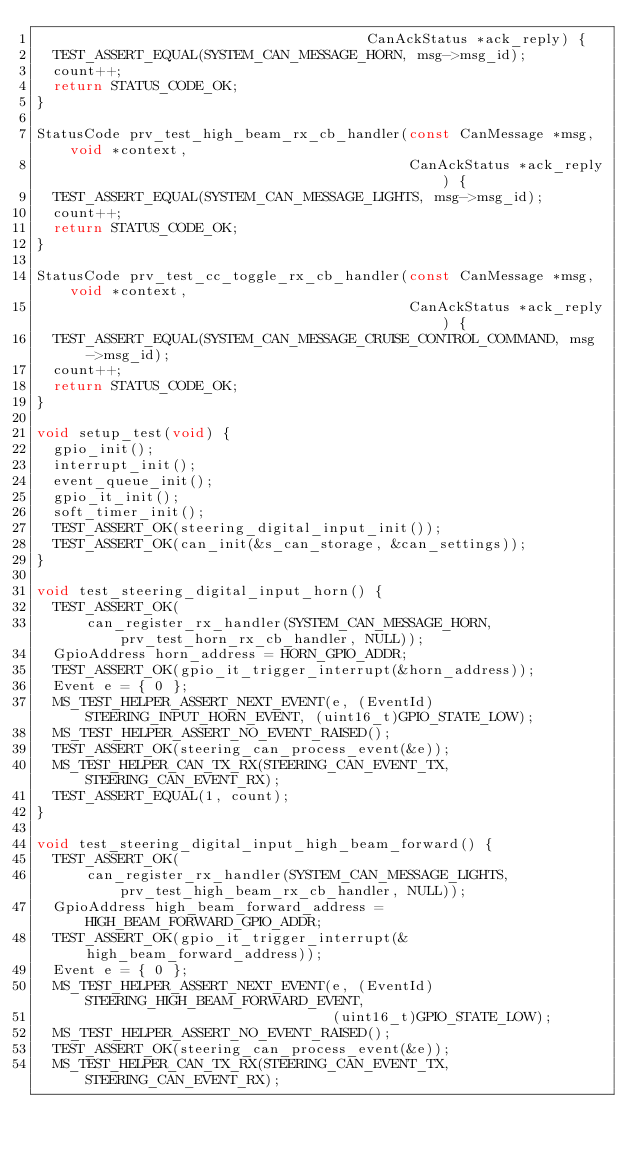<code> <loc_0><loc_0><loc_500><loc_500><_C_>                                       CanAckStatus *ack_reply) {
  TEST_ASSERT_EQUAL(SYSTEM_CAN_MESSAGE_HORN, msg->msg_id);
  count++;
  return STATUS_CODE_OK;
}

StatusCode prv_test_high_beam_rx_cb_handler(const CanMessage *msg, void *context,
                                            CanAckStatus *ack_reply) {
  TEST_ASSERT_EQUAL(SYSTEM_CAN_MESSAGE_LIGHTS, msg->msg_id);
  count++;
  return STATUS_CODE_OK;
}

StatusCode prv_test_cc_toggle_rx_cb_handler(const CanMessage *msg, void *context,
                                            CanAckStatus *ack_reply) {
  TEST_ASSERT_EQUAL(SYSTEM_CAN_MESSAGE_CRUISE_CONTROL_COMMAND, msg->msg_id);
  count++;
  return STATUS_CODE_OK;
}

void setup_test(void) {
  gpio_init();
  interrupt_init();
  event_queue_init();
  gpio_it_init();
  soft_timer_init();
  TEST_ASSERT_OK(steering_digital_input_init());
  TEST_ASSERT_OK(can_init(&s_can_storage, &can_settings));
}

void test_steering_digital_input_horn() {
  TEST_ASSERT_OK(
      can_register_rx_handler(SYSTEM_CAN_MESSAGE_HORN, prv_test_horn_rx_cb_handler, NULL));
  GpioAddress horn_address = HORN_GPIO_ADDR;
  TEST_ASSERT_OK(gpio_it_trigger_interrupt(&horn_address));
  Event e = { 0 };
  MS_TEST_HELPER_ASSERT_NEXT_EVENT(e, (EventId)STEERING_INPUT_HORN_EVENT, (uint16_t)GPIO_STATE_LOW);
  MS_TEST_HELPER_ASSERT_NO_EVENT_RAISED();
  TEST_ASSERT_OK(steering_can_process_event(&e));
  MS_TEST_HELPER_CAN_TX_RX(STEERING_CAN_EVENT_TX, STEERING_CAN_EVENT_RX);
  TEST_ASSERT_EQUAL(1, count);
}

void test_steering_digital_input_high_beam_forward() {
  TEST_ASSERT_OK(
      can_register_rx_handler(SYSTEM_CAN_MESSAGE_LIGHTS, prv_test_high_beam_rx_cb_handler, NULL));
  GpioAddress high_beam_forward_address = HIGH_BEAM_FORWARD_GPIO_ADDR;
  TEST_ASSERT_OK(gpio_it_trigger_interrupt(&high_beam_forward_address));
  Event e = { 0 };
  MS_TEST_HELPER_ASSERT_NEXT_EVENT(e, (EventId)STEERING_HIGH_BEAM_FORWARD_EVENT,
                                   (uint16_t)GPIO_STATE_LOW);
  MS_TEST_HELPER_ASSERT_NO_EVENT_RAISED();
  TEST_ASSERT_OK(steering_can_process_event(&e));
  MS_TEST_HELPER_CAN_TX_RX(STEERING_CAN_EVENT_TX, STEERING_CAN_EVENT_RX);</code> 